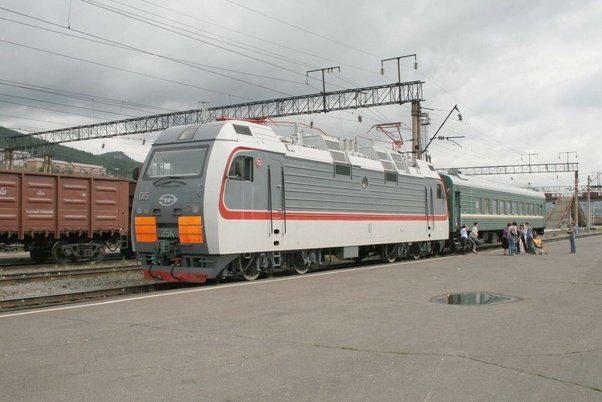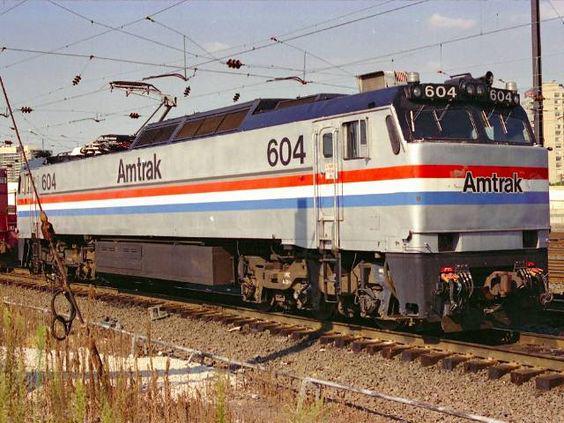The first image is the image on the left, the second image is the image on the right. Examine the images to the left and right. Is the description "Both trains are facing left." accurate? Answer yes or no. No. The first image is the image on the left, the second image is the image on the right. Considering the images on both sides, is "One of the trains features the colors red, white, and blue with a blue stripe running the entire length of the car." valid? Answer yes or no. Yes. 